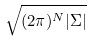Convert formula to latex. <formula><loc_0><loc_0><loc_500><loc_500>\sqrt { ( 2 \pi ) ^ { N } | \Sigma | }</formula> 